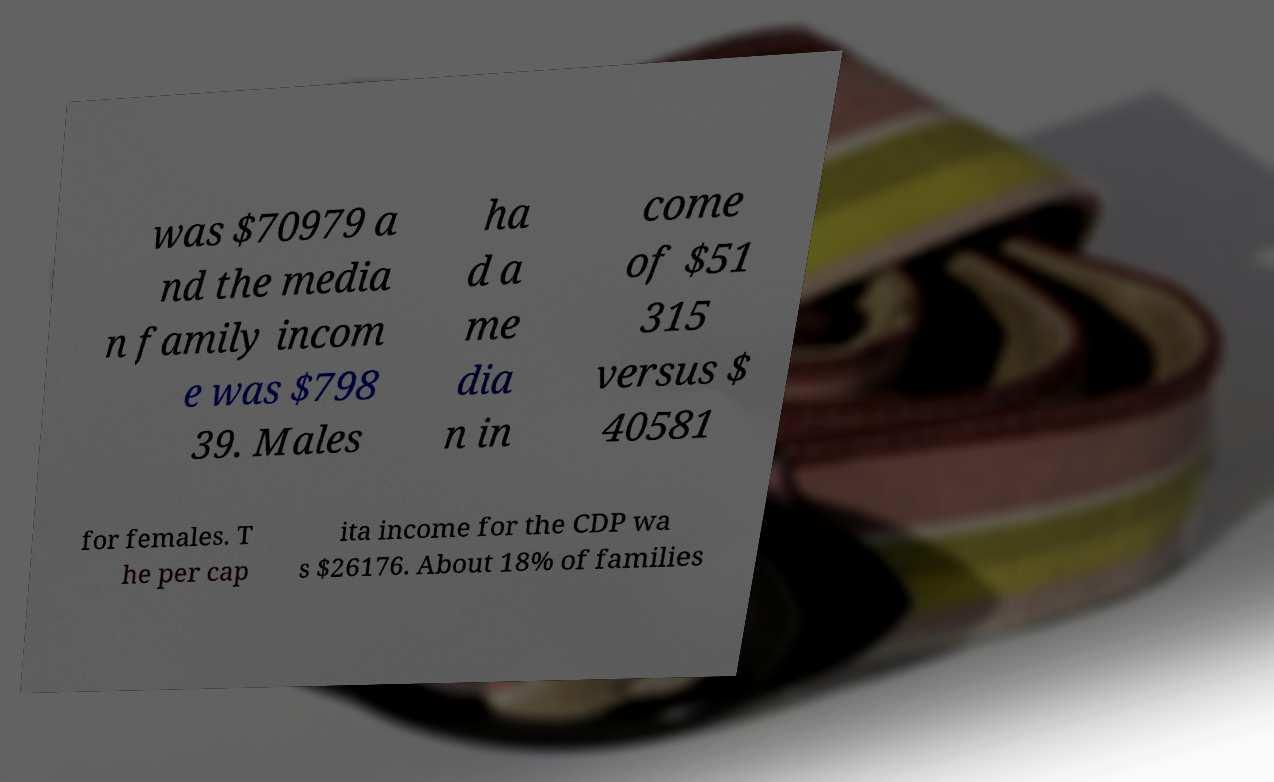What messages or text are displayed in this image? I need them in a readable, typed format. was $70979 a nd the media n family incom e was $798 39. Males ha d a me dia n in come of $51 315 versus $ 40581 for females. T he per cap ita income for the CDP wa s $26176. About 18% of families 